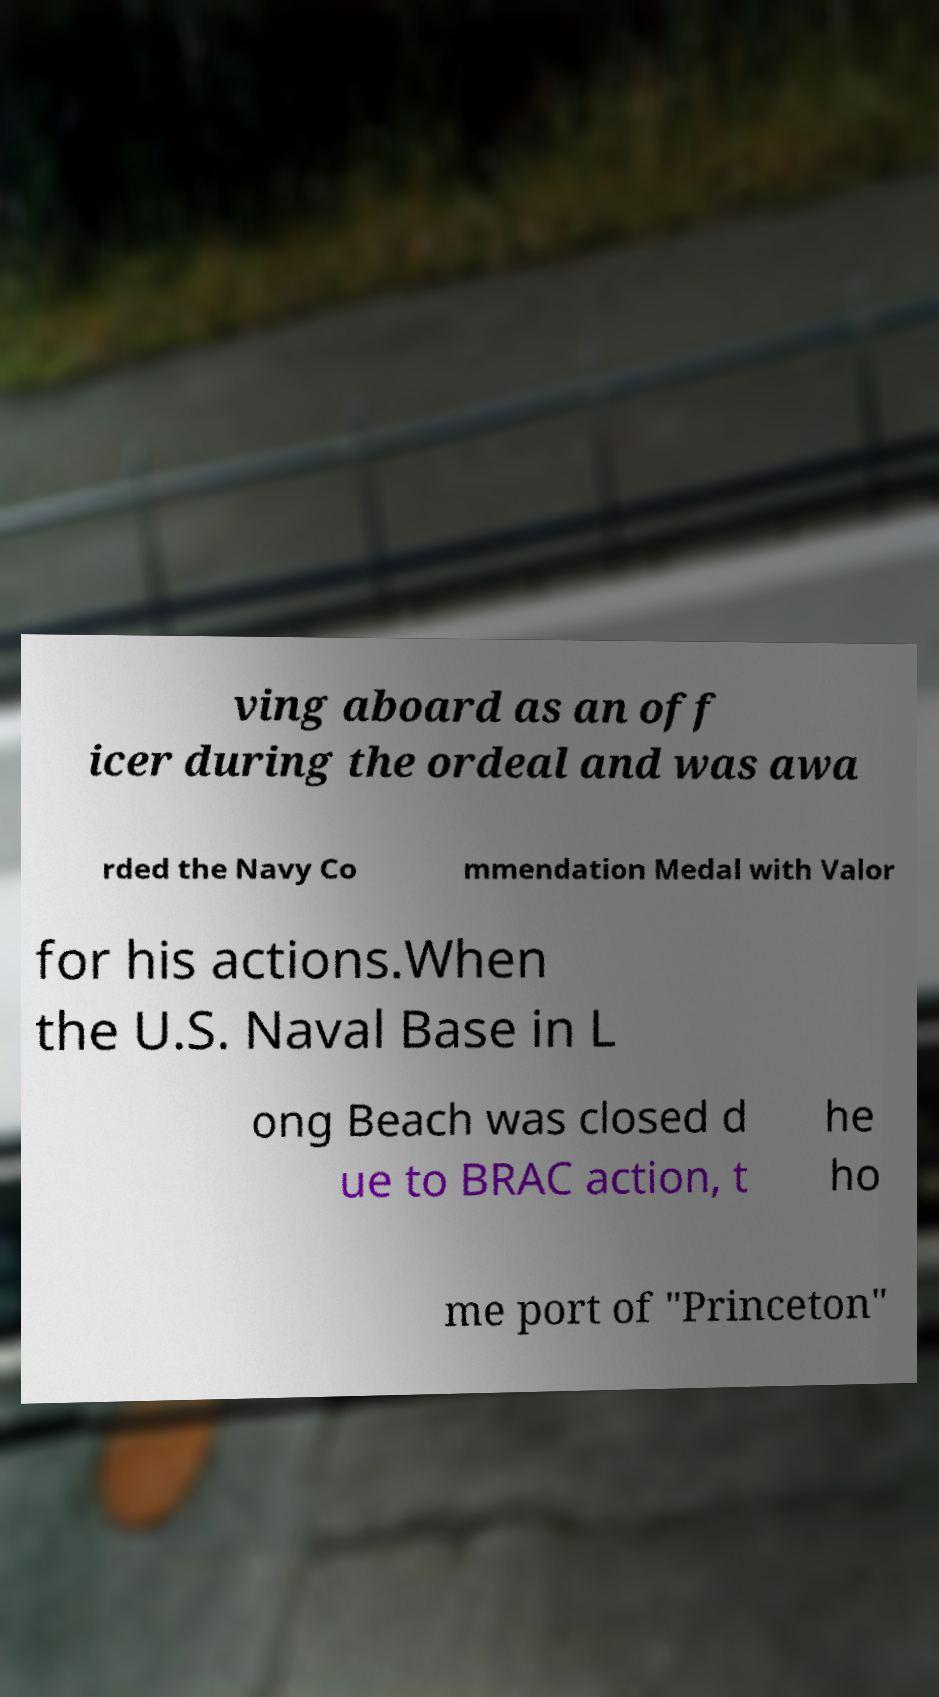I need the written content from this picture converted into text. Can you do that? ving aboard as an off icer during the ordeal and was awa rded the Navy Co mmendation Medal with Valor for his actions.When the U.S. Naval Base in L ong Beach was closed d ue to BRAC action, t he ho me port of "Princeton" 